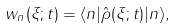Convert formula to latex. <formula><loc_0><loc_0><loc_500><loc_500>w _ { n } ( { \xi } ; t ) = \langle n | \hat { \rho } ( { \xi } ; t ) | n \rangle ,</formula> 